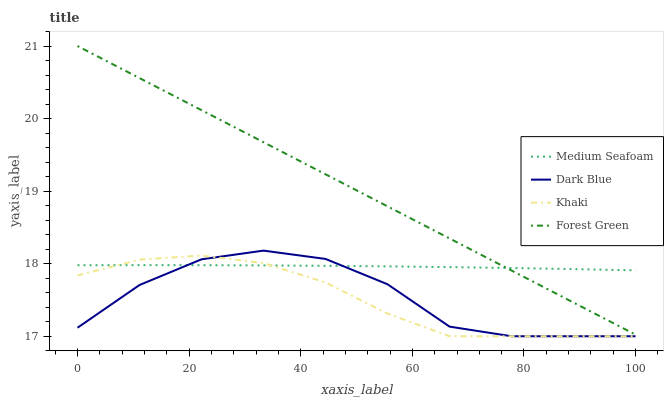Does Khaki have the minimum area under the curve?
Answer yes or no. Yes. Does Forest Green have the maximum area under the curve?
Answer yes or no. Yes. Does Forest Green have the minimum area under the curve?
Answer yes or no. No. Does Khaki have the maximum area under the curve?
Answer yes or no. No. Is Forest Green the smoothest?
Answer yes or no. Yes. Is Dark Blue the roughest?
Answer yes or no. Yes. Is Khaki the smoothest?
Answer yes or no. No. Is Khaki the roughest?
Answer yes or no. No. Does Dark Blue have the lowest value?
Answer yes or no. Yes. Does Forest Green have the lowest value?
Answer yes or no. No. Does Forest Green have the highest value?
Answer yes or no. Yes. Does Khaki have the highest value?
Answer yes or no. No. Is Khaki less than Forest Green?
Answer yes or no. Yes. Is Forest Green greater than Khaki?
Answer yes or no. Yes. Does Khaki intersect Dark Blue?
Answer yes or no. Yes. Is Khaki less than Dark Blue?
Answer yes or no. No. Is Khaki greater than Dark Blue?
Answer yes or no. No. Does Khaki intersect Forest Green?
Answer yes or no. No. 